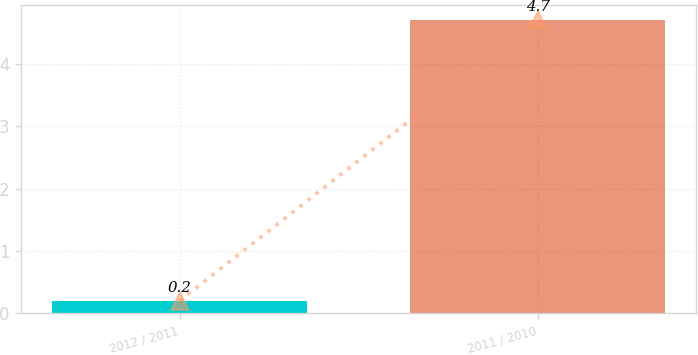<chart> <loc_0><loc_0><loc_500><loc_500><bar_chart><fcel>2012 / 2011<fcel>2011 / 2010<nl><fcel>0.2<fcel>4.7<nl></chart> 